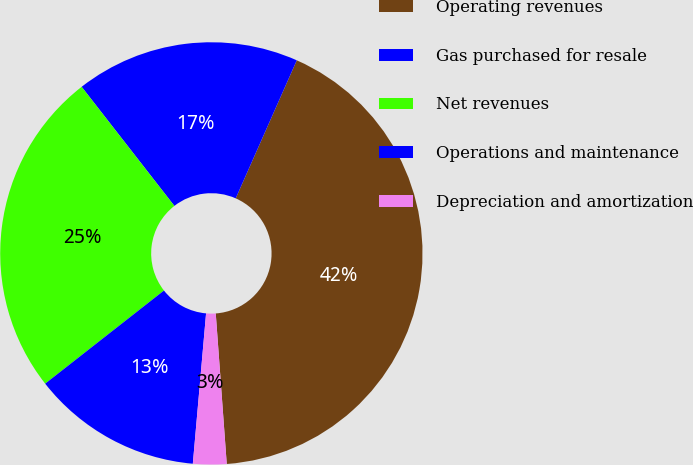Convert chart. <chart><loc_0><loc_0><loc_500><loc_500><pie_chart><fcel>Operating revenues<fcel>Gas purchased for resale<fcel>Net revenues<fcel>Operations and maintenance<fcel>Depreciation and amortization<nl><fcel>42.21%<fcel>17.16%<fcel>25.05%<fcel>13.02%<fcel>2.56%<nl></chart> 